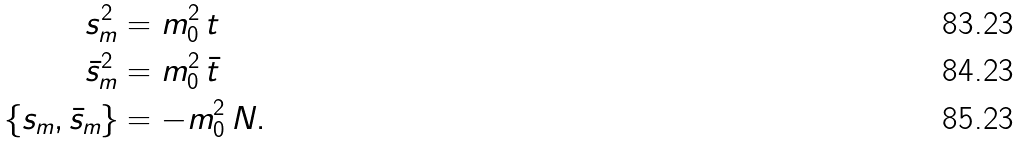<formula> <loc_0><loc_0><loc_500><loc_500>s _ { m } ^ { 2 } & = m _ { 0 } ^ { 2 } \, t \\ \bar { s } _ { m } ^ { 2 } & = m _ { 0 } ^ { 2 } \, \bar { t } \\ \{ s _ { m } , \bar { s } _ { m } \} & = - m _ { 0 } ^ { 2 } \, N .</formula> 